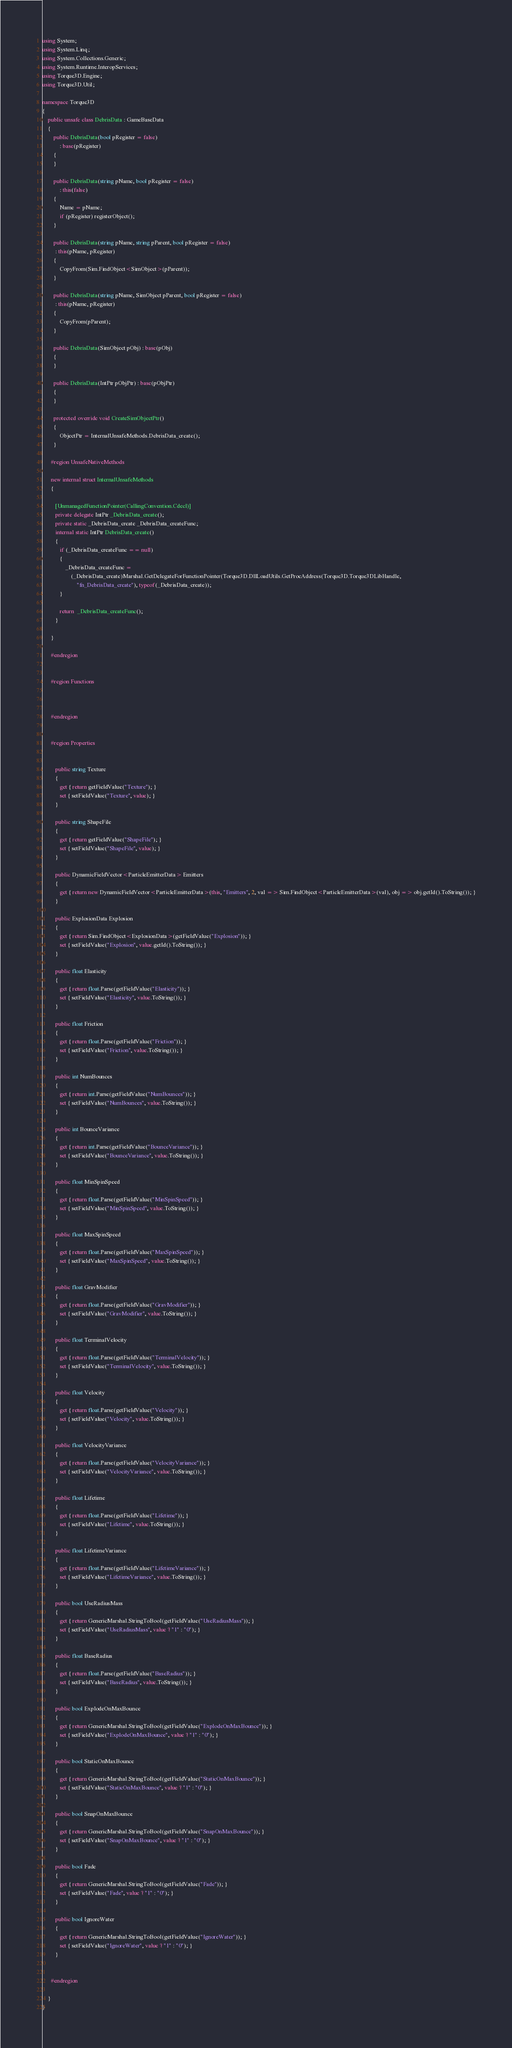Convert code to text. <code><loc_0><loc_0><loc_500><loc_500><_C#_>using System;
using System.Linq;
using System.Collections.Generic;
using System.Runtime.InteropServices;
using Torque3D.Engine;
using Torque3D.Util;

namespace Torque3D
{
	public unsafe class DebrisData : GameBaseData
	{
		public DebrisData(bool pRegister = false)
			: base(pRegister)
		{
		}

		public DebrisData(string pName, bool pRegister = false)
			: this(false)
		{
			Name = pName;
			if (pRegister) registerObject();
		}

		public DebrisData(string pName, string pParent, bool pRegister = false)
         : this(pName, pRegister)
		{
			CopyFrom(Sim.FindObject<SimObject>(pParent));
		}

		public DebrisData(string pName, SimObject pParent, bool pRegister = false)
         : this(pName, pRegister)
		{
			CopyFrom(pParent);
		}

		public DebrisData(SimObject pObj) : base(pObj)
		{
		}

		public DebrisData(IntPtr pObjPtr) : base(pObjPtr)
		{
		}

		protected override void CreateSimObjectPtr()
		{
			ObjectPtr = InternalUnsafeMethods.DebrisData_create();
		}

      #region UnsafeNativeMethods
      
      new internal struct InternalUnsafeMethods
      {
      
         [UnmanagedFunctionPointer(CallingConvention.Cdecl)]
         private delegate IntPtr _DebrisData_create();
         private static _DebrisData_create _DebrisData_createFunc;
         internal static IntPtr DebrisData_create()
         {
         	if (_DebrisData_createFunc == null)
         	{
         		_DebrisData_createFunc =
         			(_DebrisData_create)Marshal.GetDelegateForFunctionPointer(Torque3D.DllLoadUtils.GetProcAddress(Torque3D.Torque3DLibHandle,
         				"fn_DebrisData_create"), typeof(_DebrisData_create));
         	}
         
         	return  _DebrisData_createFunc();
         }
      
      }
      
      #endregion


      #region Functions
      
      
      
      #endregion


      #region Properties
      
      
         public string Texture
         {
         	get { return getFieldValue("Texture"); }
         	set { setFieldValue("Texture", value); }
         }
      
         public string ShapeFile
         {
         	get { return getFieldValue("ShapeFile"); }
         	set { setFieldValue("ShapeFile", value); }
         }
      
         public DynamicFieldVector<ParticleEmitterData> Emitters
         {
         	get { return new DynamicFieldVector<ParticleEmitterData>(this, "Emitters", 2, val => Sim.FindObject<ParticleEmitterData>(val), obj => obj.getId().ToString()); }
         }
      
         public ExplosionData Explosion
         {
         	get { return Sim.FindObject<ExplosionData>(getFieldValue("Explosion")); }
         	set { setFieldValue("Explosion", value.getId().ToString()); }
         }
      
         public float Elasticity
         {
         	get { return float.Parse(getFieldValue("Elasticity")); }
         	set { setFieldValue("Elasticity", value.ToString()); }
         }
      
         public float Friction
         {
         	get { return float.Parse(getFieldValue("Friction")); }
         	set { setFieldValue("Friction", value.ToString()); }
         }
      
         public int NumBounces
         {
         	get { return int.Parse(getFieldValue("NumBounces")); }
         	set { setFieldValue("NumBounces", value.ToString()); }
         }
      
         public int BounceVariance
         {
         	get { return int.Parse(getFieldValue("BounceVariance")); }
         	set { setFieldValue("BounceVariance", value.ToString()); }
         }
      
         public float MinSpinSpeed
         {
         	get { return float.Parse(getFieldValue("MinSpinSpeed")); }
         	set { setFieldValue("MinSpinSpeed", value.ToString()); }
         }
      
         public float MaxSpinSpeed
         {
         	get { return float.Parse(getFieldValue("MaxSpinSpeed")); }
         	set { setFieldValue("MaxSpinSpeed", value.ToString()); }
         }
      
         public float GravModifier
         {
         	get { return float.Parse(getFieldValue("GravModifier")); }
         	set { setFieldValue("GravModifier", value.ToString()); }
         }
      
         public float TerminalVelocity
         {
         	get { return float.Parse(getFieldValue("TerminalVelocity")); }
         	set { setFieldValue("TerminalVelocity", value.ToString()); }
         }
      
         public float Velocity
         {
         	get { return float.Parse(getFieldValue("Velocity")); }
         	set { setFieldValue("Velocity", value.ToString()); }
         }
      
         public float VelocityVariance
         {
         	get { return float.Parse(getFieldValue("VelocityVariance")); }
         	set { setFieldValue("VelocityVariance", value.ToString()); }
         }
      
         public float Lifetime
         {
         	get { return float.Parse(getFieldValue("Lifetime")); }
         	set { setFieldValue("Lifetime", value.ToString()); }
         }
      
         public float LifetimeVariance
         {
         	get { return float.Parse(getFieldValue("LifetimeVariance")); }
         	set { setFieldValue("LifetimeVariance", value.ToString()); }
         }
      
         public bool UseRadiusMass
         {
         	get { return GenericMarshal.StringToBool(getFieldValue("UseRadiusMass")); }
         	set { setFieldValue("UseRadiusMass", value ? "1" : "0"); }
         }
      
         public float BaseRadius
         {
         	get { return float.Parse(getFieldValue("BaseRadius")); }
         	set { setFieldValue("BaseRadius", value.ToString()); }
         }
      
         public bool ExplodeOnMaxBounce
         {
         	get { return GenericMarshal.StringToBool(getFieldValue("ExplodeOnMaxBounce")); }
         	set { setFieldValue("ExplodeOnMaxBounce", value ? "1" : "0"); }
         }
      
         public bool StaticOnMaxBounce
         {
         	get { return GenericMarshal.StringToBool(getFieldValue("StaticOnMaxBounce")); }
         	set { setFieldValue("StaticOnMaxBounce", value ? "1" : "0"); }
         }
      
         public bool SnapOnMaxBounce
         {
         	get { return GenericMarshal.StringToBool(getFieldValue("SnapOnMaxBounce")); }
         	set { setFieldValue("SnapOnMaxBounce", value ? "1" : "0"); }
         }
      
         public bool Fade
         {
         	get { return GenericMarshal.StringToBool(getFieldValue("Fade")); }
         	set { setFieldValue("Fade", value ? "1" : "0"); }
         }
      
         public bool IgnoreWater
         {
         	get { return GenericMarshal.StringToBool(getFieldValue("IgnoreWater")); }
         	set { setFieldValue("IgnoreWater", value ? "1" : "0"); }
         }
      
      
      #endregion

	}
}</code> 